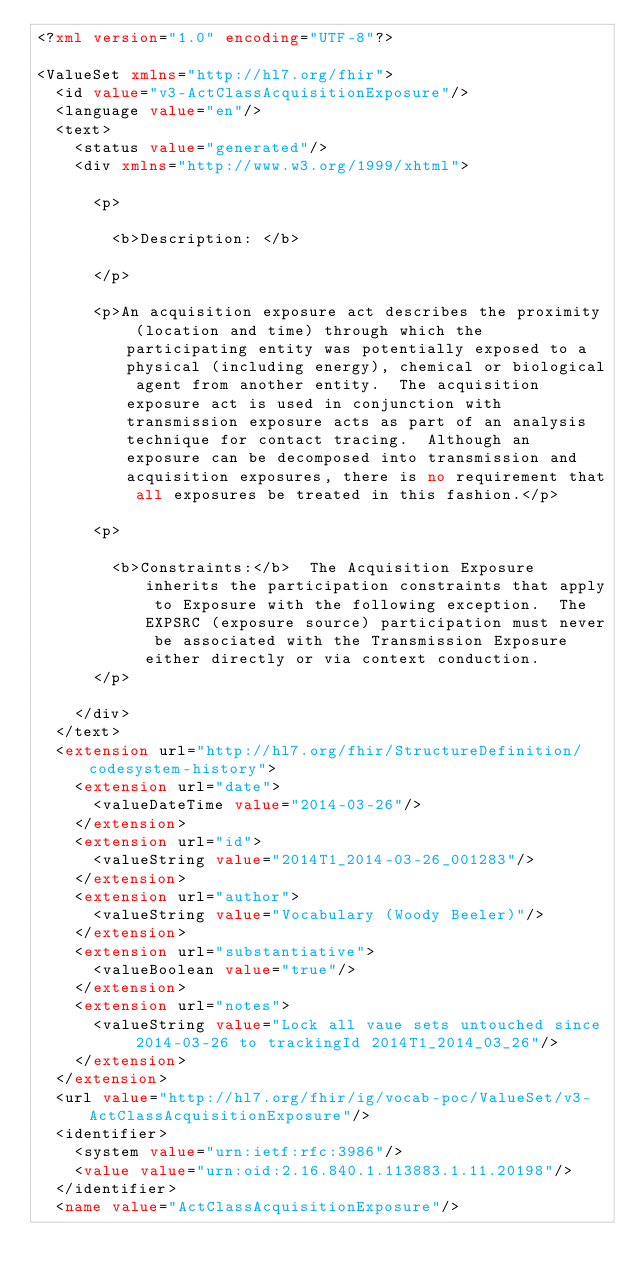Convert code to text. <code><loc_0><loc_0><loc_500><loc_500><_XML_><?xml version="1.0" encoding="UTF-8"?>

<ValueSet xmlns="http://hl7.org/fhir">
  <id value="v3-ActClassAcquisitionExposure"/>
  <language value="en"/>
  <text>
    <status value="generated"/>
    <div xmlns="http://www.w3.org/1999/xhtml">
                  
      <p>
                     
        <b>Description: </b>
                  
      </p>
                  
      <p>An acquisition exposure act describes the proximity (location and time) through which the participating entity was potentially exposed to a physical (including energy), chemical or biological agent from another entity.  The acquisition exposure act is used in conjunction with transmission exposure acts as part of an analysis technique for contact tracing.  Although an exposure can be decomposed into transmission and acquisition exposures, there is no requirement that all exposures be treated in this fashion.</p>
                  
      <p>
                     
        <b>Constraints:</b>  The Acquisition Exposure inherits the participation constraints that apply to Exposure with the following exception.  The EXPSRC (exposure source) participation must never be associated with the Transmission Exposure either directly or via context conduction.
      </p>
               
    </div>
  </text>
  <extension url="http://hl7.org/fhir/StructureDefinition/codesystem-history">
    <extension url="date">
      <valueDateTime value="2014-03-26"/>
    </extension>
    <extension url="id">
      <valueString value="2014T1_2014-03-26_001283"/>
    </extension>
    <extension url="author">
      <valueString value="Vocabulary (Woody Beeler)"/>
    </extension>
    <extension url="substantiative">
      <valueBoolean value="true"/>
    </extension>
    <extension url="notes">
      <valueString value="Lock all vaue sets untouched since 2014-03-26 to trackingId 2014T1_2014_03_26"/>
    </extension>
  </extension>
  <url value="http://hl7.org/fhir/ig/vocab-poc/ValueSet/v3-ActClassAcquisitionExposure"/>
  <identifier>
    <system value="urn:ietf:rfc:3986"/>
    <value value="urn:oid:2.16.840.1.113883.1.11.20198"/>
  </identifier>
  <name value="ActClassAcquisitionExposure"/></code> 